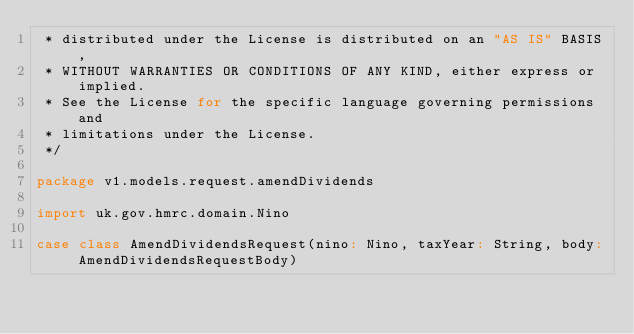Convert code to text. <code><loc_0><loc_0><loc_500><loc_500><_Scala_> * distributed under the License is distributed on an "AS IS" BASIS,
 * WITHOUT WARRANTIES OR CONDITIONS OF ANY KIND, either express or implied.
 * See the License for the specific language governing permissions and
 * limitations under the License.
 */

package v1.models.request.amendDividends

import uk.gov.hmrc.domain.Nino

case class AmendDividendsRequest(nino: Nino, taxYear: String, body: AmendDividendsRequestBody)
</code> 